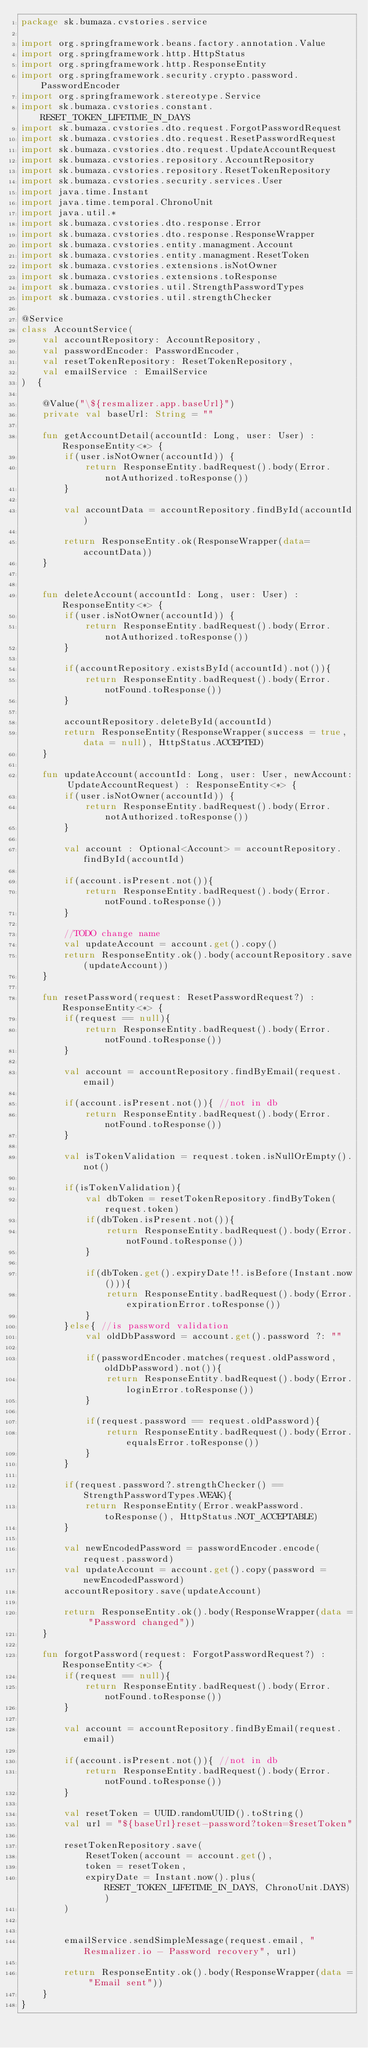Convert code to text. <code><loc_0><loc_0><loc_500><loc_500><_Kotlin_>package sk.bumaza.cvstories.service

import org.springframework.beans.factory.annotation.Value
import org.springframework.http.HttpStatus
import org.springframework.http.ResponseEntity
import org.springframework.security.crypto.password.PasswordEncoder
import org.springframework.stereotype.Service
import sk.bumaza.cvstories.constant.RESET_TOKEN_LIFETIME_IN_DAYS
import sk.bumaza.cvstories.dto.request.ForgotPasswordRequest
import sk.bumaza.cvstories.dto.request.ResetPasswordRequest
import sk.bumaza.cvstories.dto.request.UpdateAccountRequest
import sk.bumaza.cvstories.repository.AccountRepository
import sk.bumaza.cvstories.repository.ResetTokenRepository
import sk.bumaza.cvstories.security.services.User
import java.time.Instant
import java.time.temporal.ChronoUnit
import java.util.*
import sk.bumaza.cvstories.dto.response.Error
import sk.bumaza.cvstories.dto.response.ResponseWrapper
import sk.bumaza.cvstories.entity.managment.Account
import sk.bumaza.cvstories.entity.managment.ResetToken
import sk.bumaza.cvstories.extensions.isNotOwner
import sk.bumaza.cvstories.extensions.toResponse
import sk.bumaza.cvstories.util.StrengthPasswordTypes
import sk.bumaza.cvstories.util.strengthChecker

@Service
class AccountService(
    val accountRepository: AccountRepository,
    val passwordEncoder: PasswordEncoder,
    val resetTokenRepository: ResetTokenRepository,
    val emailService : EmailService
)  {

    @Value("\${resmalizer.app.baseUrl}")
    private val baseUrl: String = ""

    fun getAccountDetail(accountId: Long, user: User) : ResponseEntity<*> {
        if(user.isNotOwner(accountId)) {
            return ResponseEntity.badRequest().body(Error.notAuthorized.toResponse())
        }

        val accountData = accountRepository.findById(accountId)

        return ResponseEntity.ok(ResponseWrapper(data=accountData))
    }


    fun deleteAccount(accountId: Long, user: User) : ResponseEntity<*> {
        if(user.isNotOwner(accountId)) {
            return ResponseEntity.badRequest().body(Error.notAuthorized.toResponse())
        }

        if(accountRepository.existsById(accountId).not()){
            return ResponseEntity.badRequest().body(Error.notFound.toResponse())
        }

        accountRepository.deleteById(accountId)
        return ResponseEntity(ResponseWrapper(success = true, data = null), HttpStatus.ACCEPTED)
    }

    fun updateAccount(accountId: Long, user: User, newAccount: UpdateAccountRequest) : ResponseEntity<*> {
        if(user.isNotOwner(accountId)) {
            return ResponseEntity.badRequest().body(Error.notAuthorized.toResponse())
        }

        val account : Optional<Account> = accountRepository.findById(accountId)

        if(account.isPresent.not()){
            return ResponseEntity.badRequest().body(Error.notFound.toResponse())
        }

        //TODO change name
        val updateAccount = account.get().copy()
        return ResponseEntity.ok().body(accountRepository.save(updateAccount))
    }

    fun resetPassword(request: ResetPasswordRequest?) : ResponseEntity<*> {
        if(request == null){
            return ResponseEntity.badRequest().body(Error.notFound.toResponse())
        }

        val account = accountRepository.findByEmail(request.email)

        if(account.isPresent.not()){ //not in db
            return ResponseEntity.badRequest().body(Error.notFound.toResponse())
        }

        val isTokenValidation = request.token.isNullOrEmpty().not()

        if(isTokenValidation){
            val dbToken = resetTokenRepository.findByToken(request.token)
            if(dbToken.isPresent.not()){
                return ResponseEntity.badRequest().body(Error.notFound.toResponse())
            }

            if(dbToken.get().expiryDate!!.isBefore(Instant.now())){
                return ResponseEntity.badRequest().body(Error.expirationError.toResponse())
            }
        }else{ //is password validation
            val oldDbPassword = account.get().password ?: ""

            if(passwordEncoder.matches(request.oldPassword, oldDbPassword).not()){
                return ResponseEntity.badRequest().body(Error.loginError.toResponse())
            }

            if(request.password == request.oldPassword){
                return ResponseEntity.badRequest().body(Error.equalsError.toResponse())
            }
        }

        if(request.password?.strengthChecker() == StrengthPasswordTypes.WEAK){
            return ResponseEntity(Error.weakPassword.toResponse(), HttpStatus.NOT_ACCEPTABLE)
        }

        val newEncodedPassword = passwordEncoder.encode(request.password)
        val updateAccount = account.get().copy(password = newEncodedPassword)
        accountRepository.save(updateAccount)

        return ResponseEntity.ok().body(ResponseWrapper(data = "Password changed"))
    }

    fun forgotPassword(request: ForgotPasswordRequest?) : ResponseEntity<*> {
        if(request == null){
            return ResponseEntity.badRequest().body(Error.notFound.toResponse())
        }

        val account = accountRepository.findByEmail(request.email)

        if(account.isPresent.not()){ //not in db
            return ResponseEntity.badRequest().body(Error.notFound.toResponse())
        }

        val resetToken = UUID.randomUUID().toString()
        val url = "${baseUrl}reset-password?token=$resetToken"

        resetTokenRepository.save(
            ResetToken(account = account.get(),
            token = resetToken,
            expiryDate = Instant.now().plus(RESET_TOKEN_LIFETIME_IN_DAYS, ChronoUnit.DAYS))
        )


        emailService.sendSimpleMessage(request.email, "Resmalizer.io - Password recovery", url)

        return ResponseEntity.ok().body(ResponseWrapper(data = "Email sent"))
    }
}</code> 